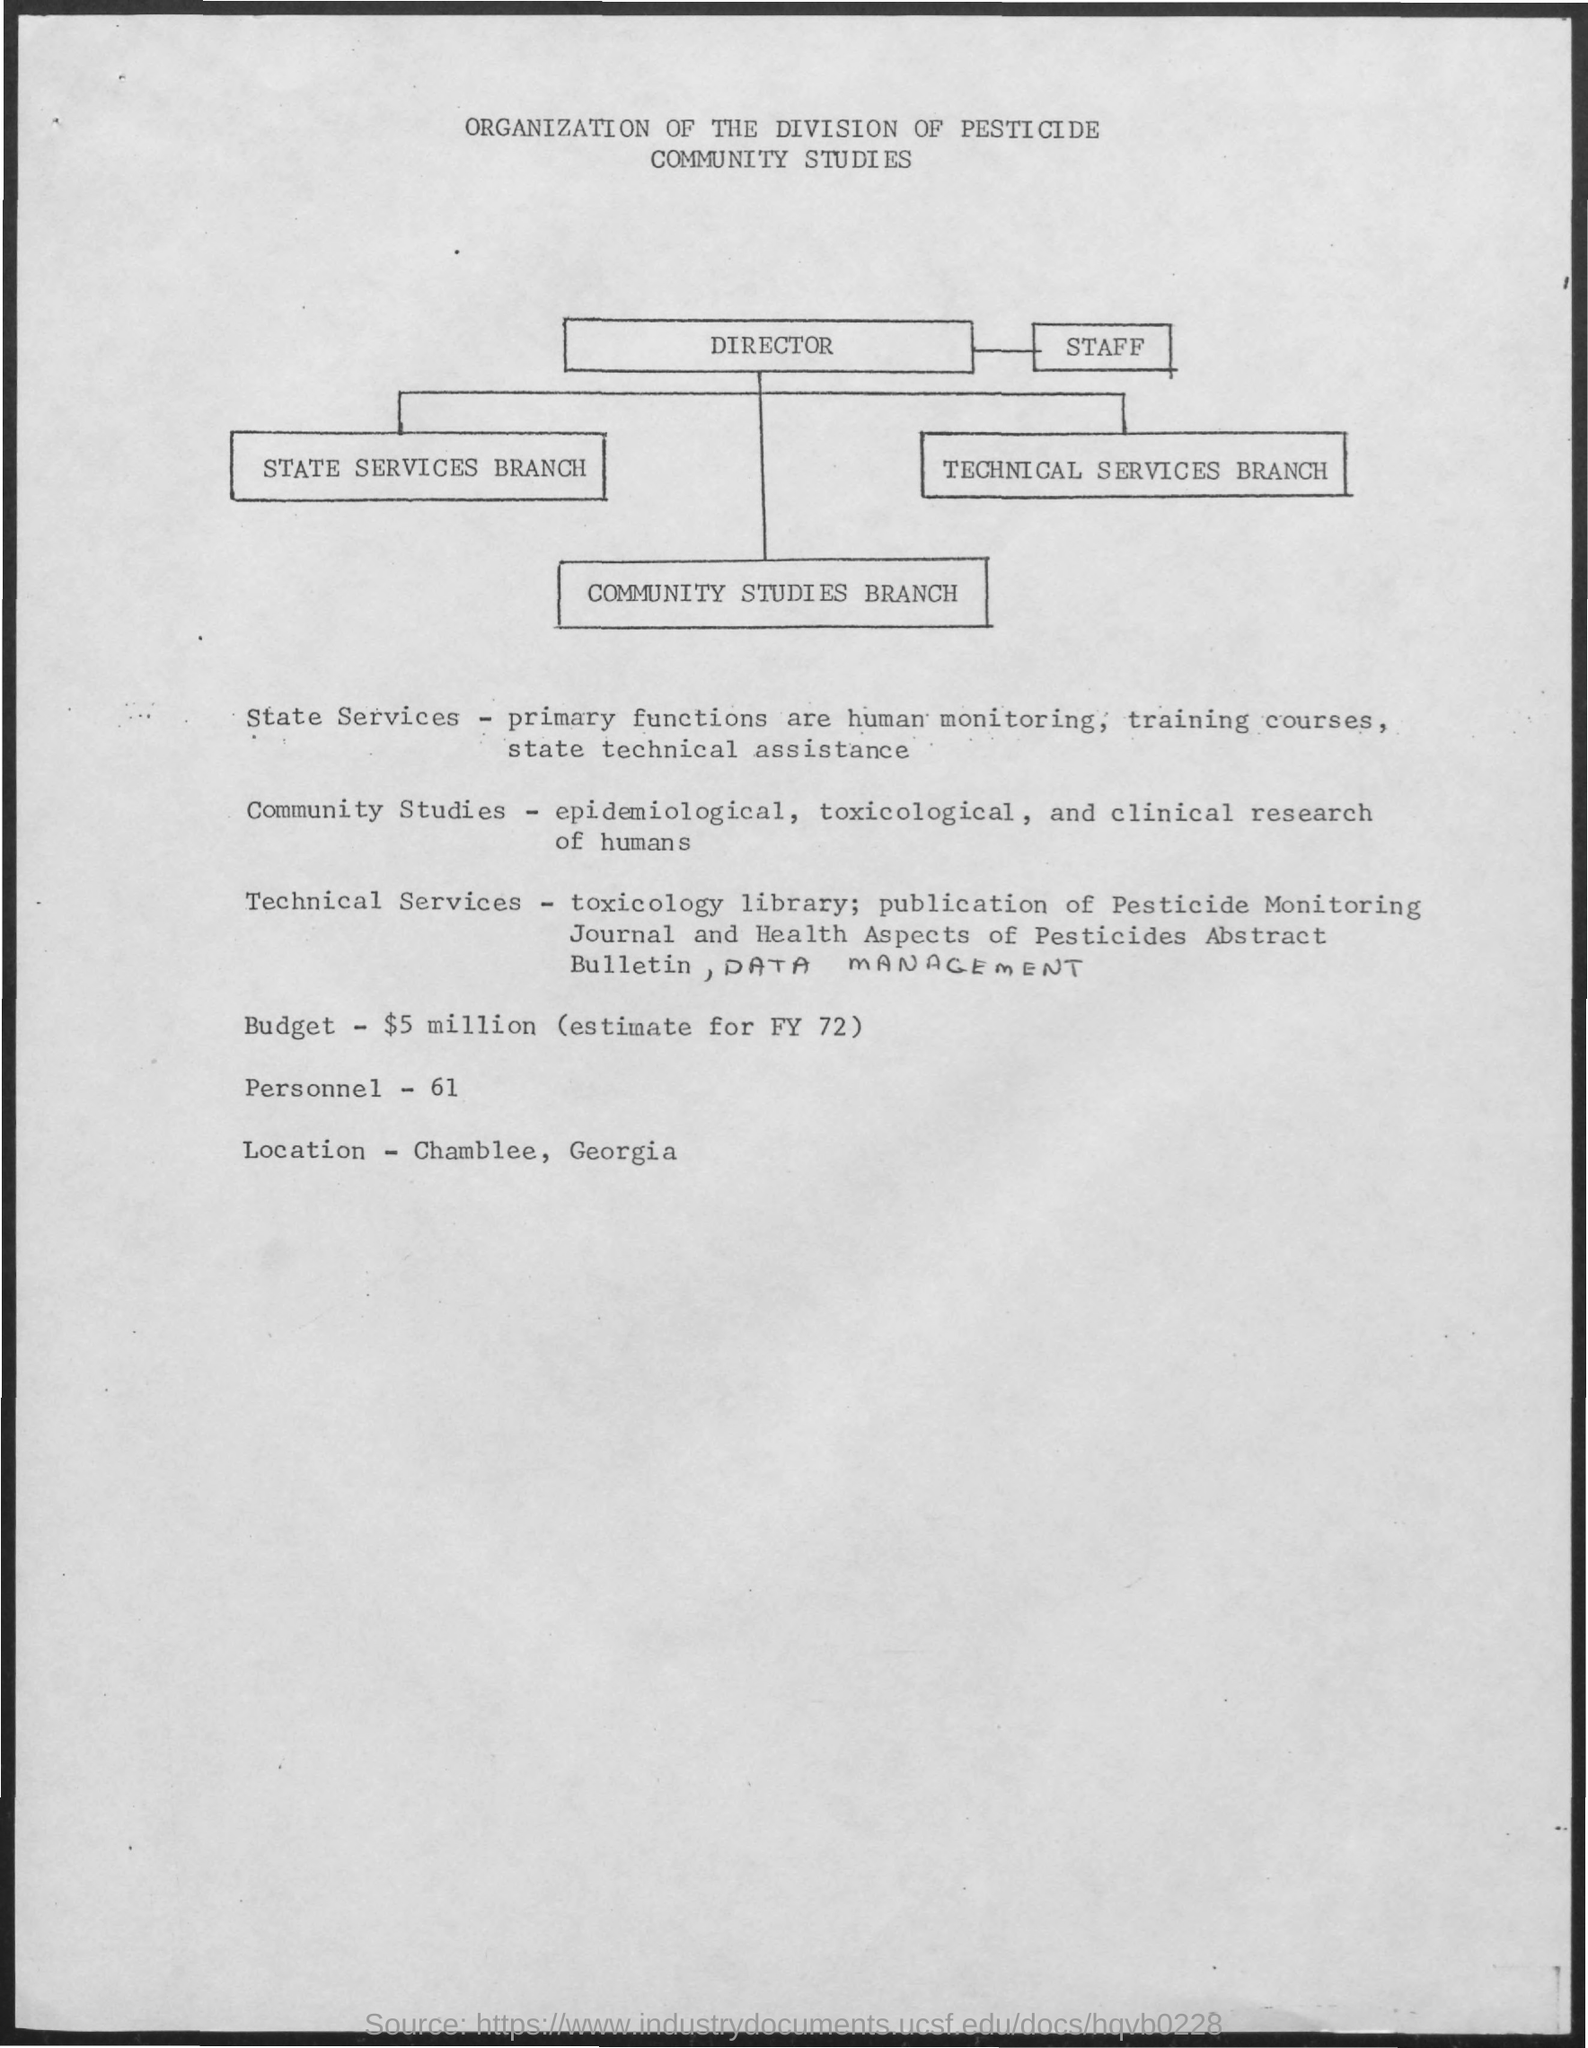What is the Budget?
Your answer should be very brief. $5 million (estimate for FY 72). How many Personnel?
Give a very brief answer. 61. What is the Location?
Offer a terse response. Chamblee, Georgia. Whose primary functions are human monitoring, training courses, state technical assistance?
Your answer should be compact. State Services. 